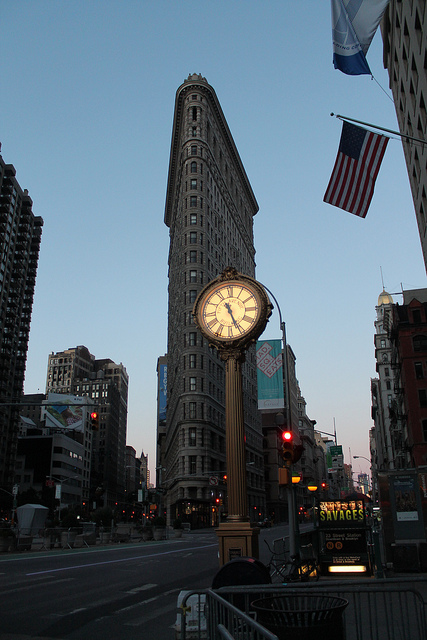Please identify all text content in this image. SAVAGES XII V VII VI III I 